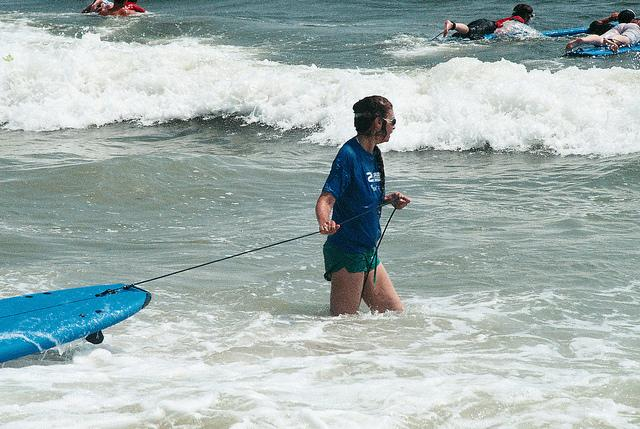What are surfboards made out of? fiberglass 